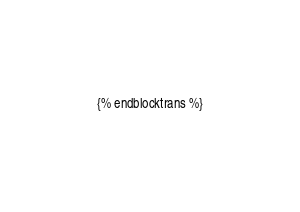<code> <loc_0><loc_0><loc_500><loc_500><_HTML_>{% endblocktrans %}
</code> 